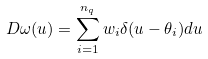<formula> <loc_0><loc_0><loc_500><loc_500>\ D \omega ( u ) = \sum _ { i = 1 } ^ { n _ { q } } w _ { i } \delta ( u - \theta _ { i } ) d u</formula> 